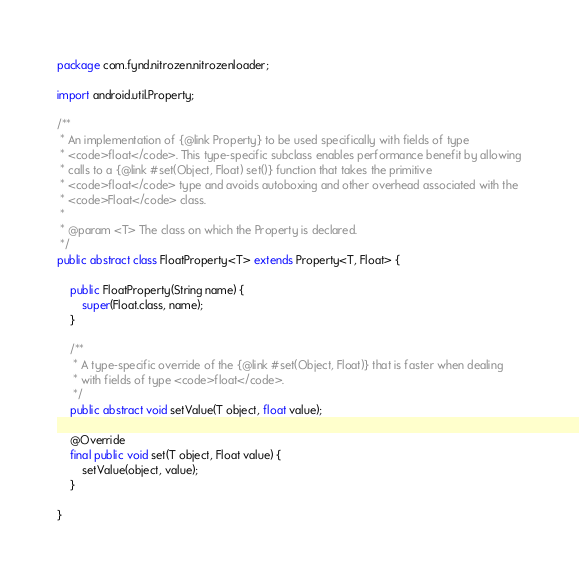<code> <loc_0><loc_0><loc_500><loc_500><_Java_>package com.fynd.nitrozen.nitrozenloader;

import android.util.Property;

/**
 * An implementation of {@link Property} to be used specifically with fields of type
 * <code>float</code>. This type-specific subclass enables performance benefit by allowing
 * calls to a {@link #set(Object, Float) set()} function that takes the primitive
 * <code>float</code> type and avoids autoboxing and other overhead associated with the
 * <code>Float</code> class.
 *
 * @param <T> The class on which the Property is declared.
 */
public abstract class FloatProperty<T> extends Property<T, Float> {

    public FloatProperty(String name) {
        super(Float.class, name);
    }

    /**
     * A type-specific override of the {@link #set(Object, Float)} that is faster when dealing
     * with fields of type <code>float</code>.
     */
    public abstract void setValue(T object, float value);

    @Override
    final public void set(T object, Float value) {
        setValue(object, value);
    }

}</code> 